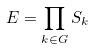Convert formula to latex. <formula><loc_0><loc_0><loc_500><loc_500>E = \prod _ { k \in G } S _ { k }</formula> 